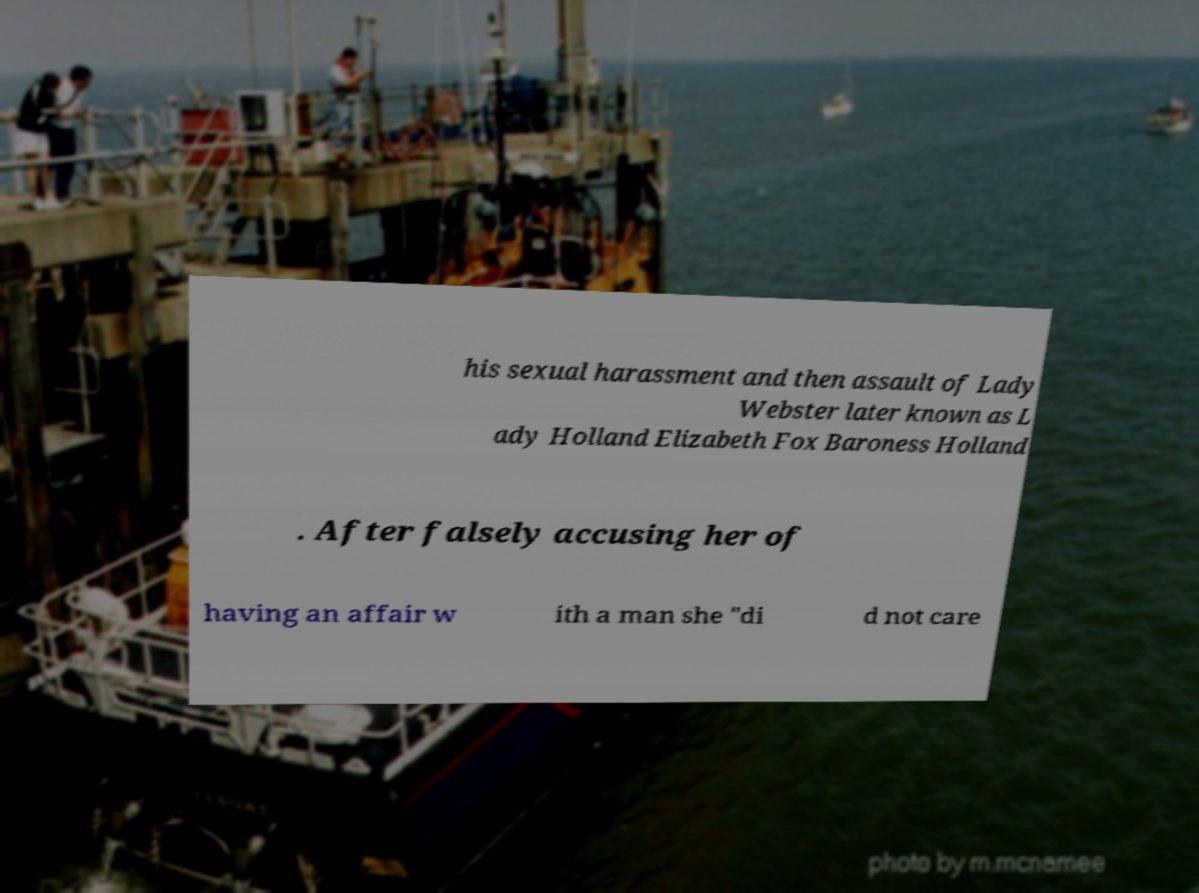Could you extract and type out the text from this image? his sexual harassment and then assault of Lady Webster later known as L ady Holland Elizabeth Fox Baroness Holland . After falsely accusing her of having an affair w ith a man she "di d not care 